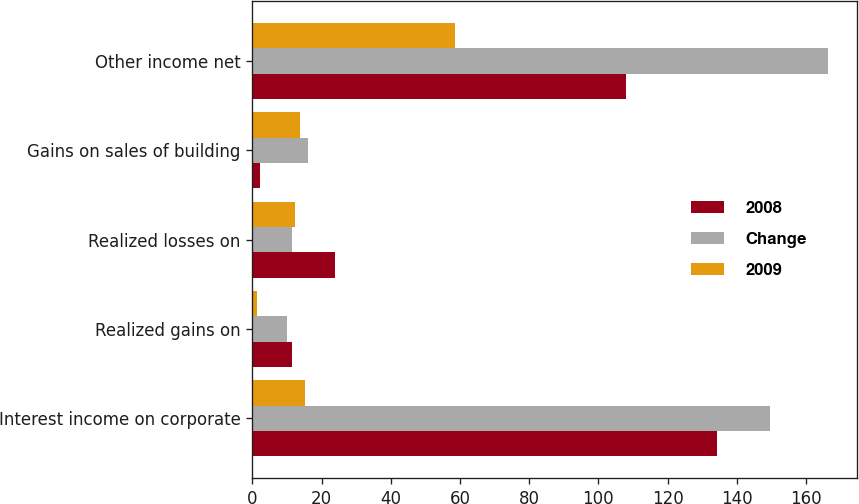Convert chart to OTSL. <chart><loc_0><loc_0><loc_500><loc_500><stacked_bar_chart><ecel><fcel>Interest income on corporate<fcel>Realized gains on<fcel>Realized losses on<fcel>Gains on sales of building<fcel>Other income net<nl><fcel>2008<fcel>134.2<fcel>11.4<fcel>23.8<fcel>2.2<fcel>108<nl><fcel>Change<fcel>149.5<fcel>10.1<fcel>11.4<fcel>16<fcel>166.5<nl><fcel>2009<fcel>15.3<fcel>1.3<fcel>12.4<fcel>13.8<fcel>58.5<nl></chart> 